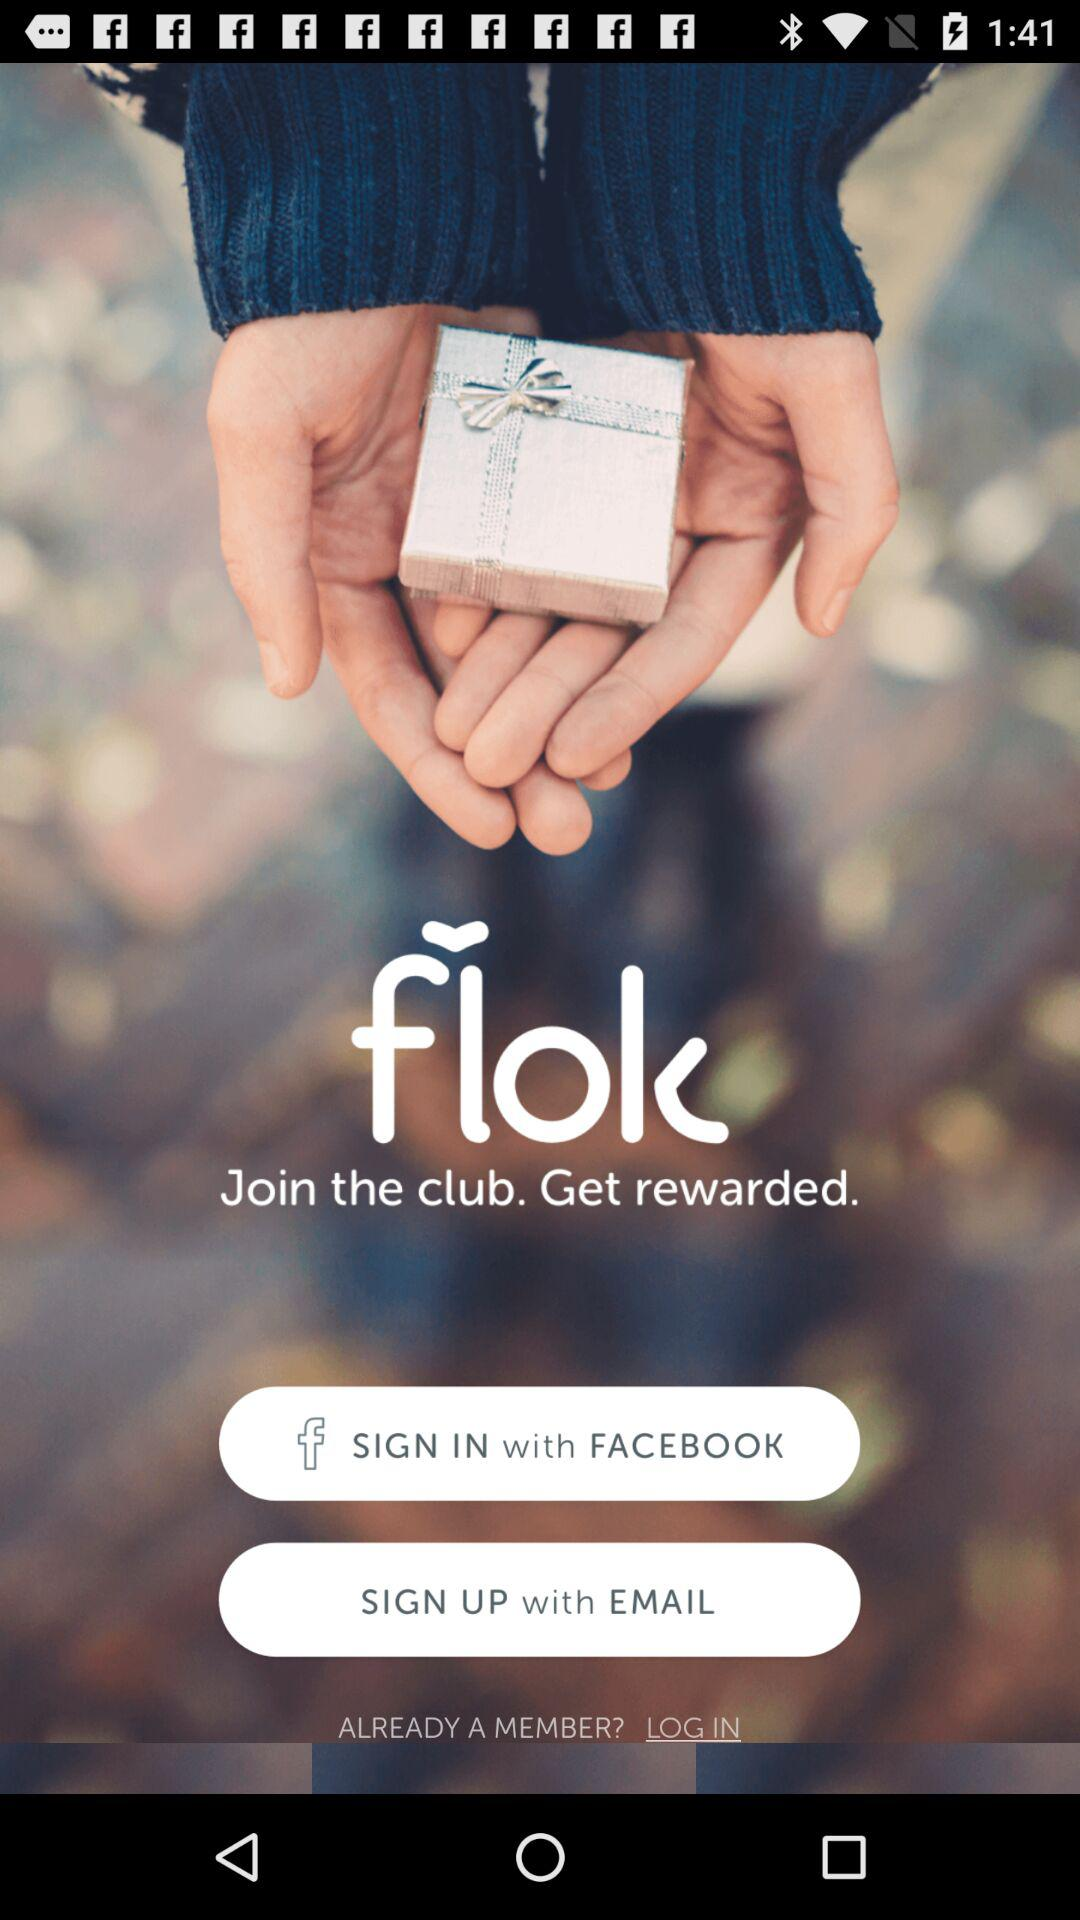What is the app name? The name of the app is "flok". 